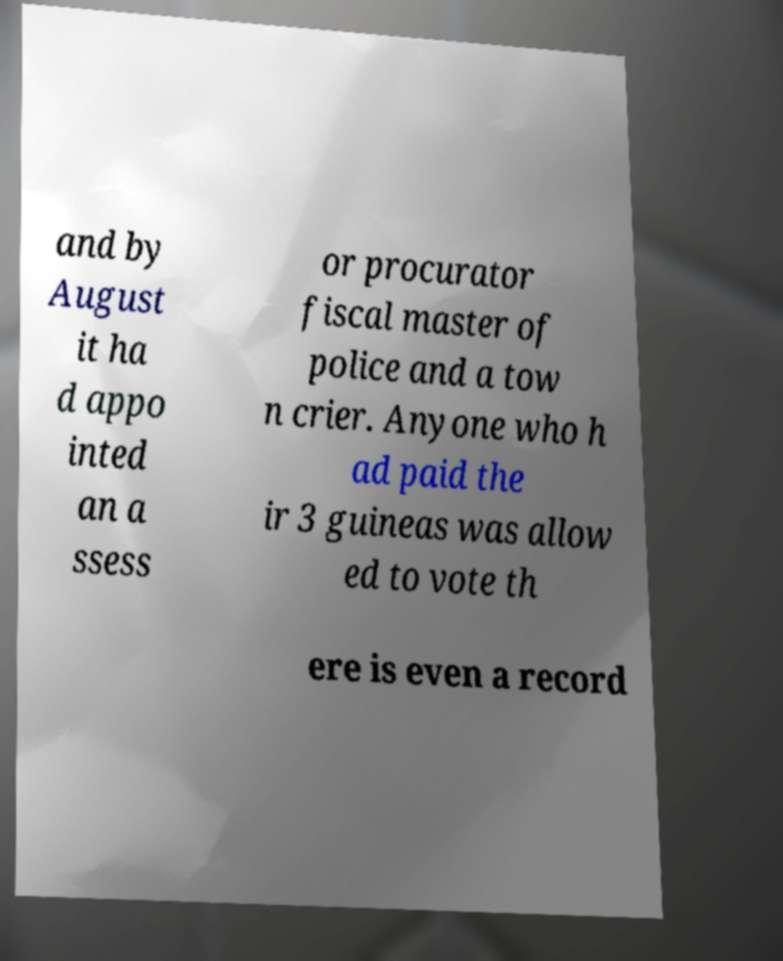What messages or text are displayed in this image? I need them in a readable, typed format. and by August it ha d appo inted an a ssess or procurator fiscal master of police and a tow n crier. Anyone who h ad paid the ir 3 guineas was allow ed to vote th ere is even a record 